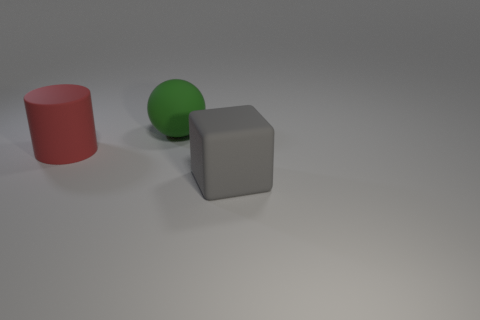Subtract 1 spheres. How many spheres are left? 0 Add 3 purple matte blocks. How many objects exist? 6 Subtract 0 cyan cylinders. How many objects are left? 3 Subtract all cylinders. How many objects are left? 2 Subtract all gray cylinders. Subtract all blue cubes. How many cylinders are left? 1 Subtract all red blocks. How many blue balls are left? 0 Subtract all tiny yellow metal cubes. Subtract all large green balls. How many objects are left? 2 Add 2 red cylinders. How many red cylinders are left? 3 Add 2 big gray objects. How many big gray objects exist? 3 